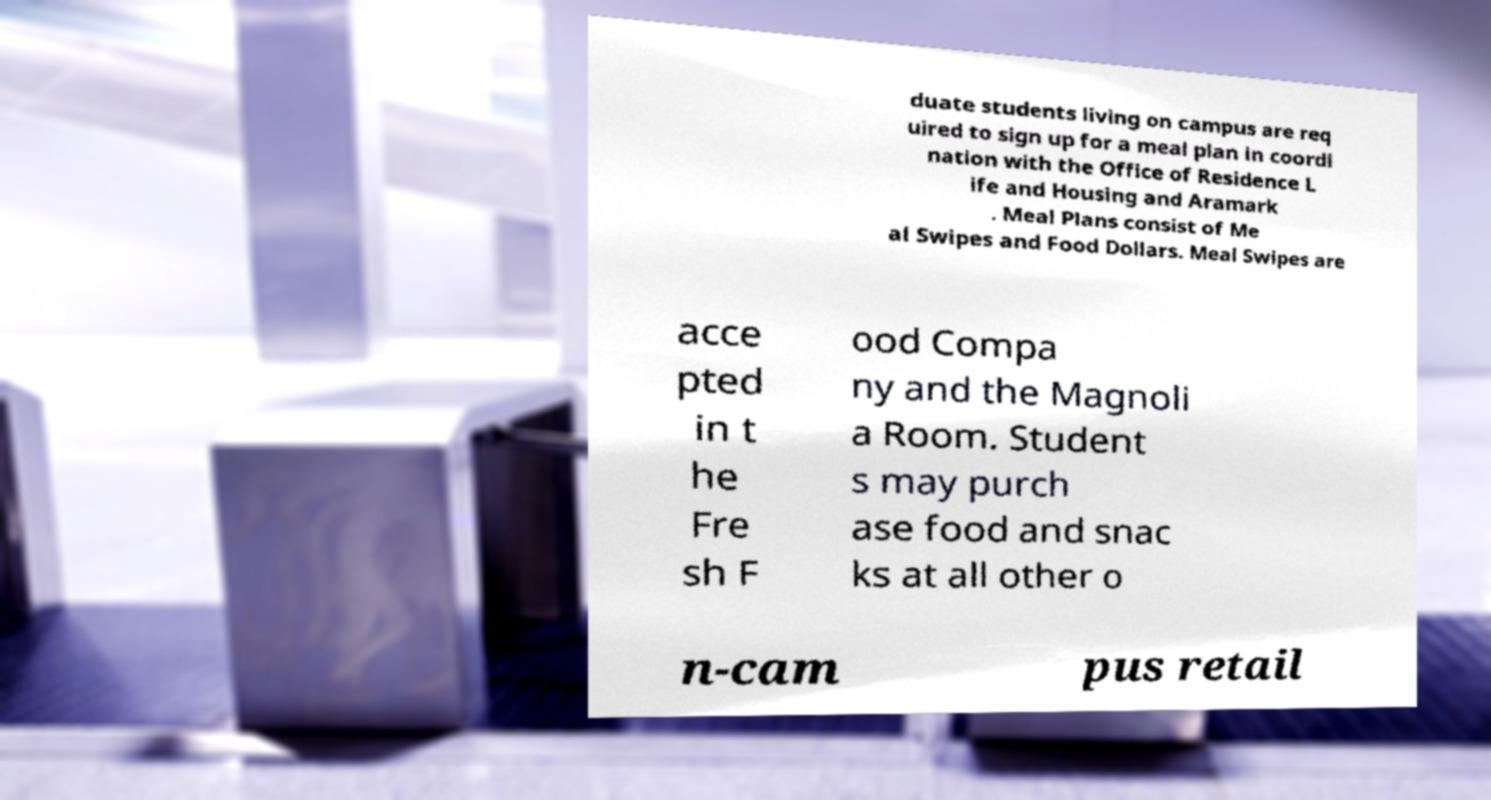Could you extract and type out the text from this image? duate students living on campus are req uired to sign up for a meal plan in coordi nation with the Office of Residence L ife and Housing and Aramark . Meal Plans consist of Me al Swipes and Food Dollars. Meal Swipes are acce pted in t he Fre sh F ood Compa ny and the Magnoli a Room. Student s may purch ase food and snac ks at all other o n-cam pus retail 